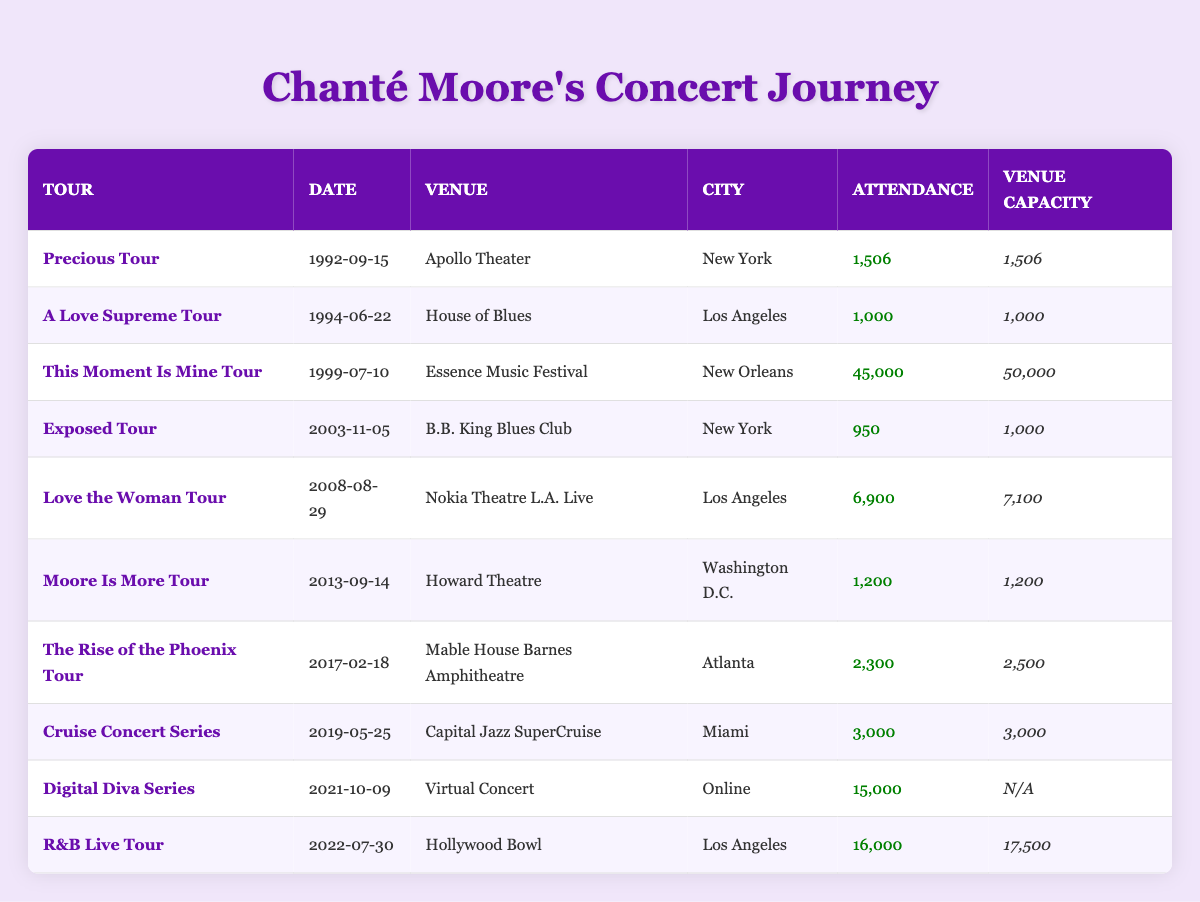What was the largest concert attendance in Chanté Moore's career? Looking at the attendance column, the highest recorded attendance is 45,000 at the Essence Music Festival on July 10, 1999.
Answer: 45,000 Which venue had the highest capacity that Chanté Moore performed at? By reviewing the venue capacity column, the highest capacity listed is 50,000 at the Essence Music Festival.
Answer: 50,000 How many concerts did Chanté Moore perform in Los Angeles? By filtering the table for concerts held in Los Angeles, there are 4 concerts listed: House of Blues, Nokia Theatre L.A. Live, and Hollywood Bowl, all in different years.
Answer: 4 What is the average attendance across all concerts? To find the average, sum the attendances: 1506 + 1000 + 45000 + 950 + 6900 + 1200 + 2300 + 3000 + 15000 + 16000 = 117,856. Then, divide by the number of concerts (10): 117,856 / 10 = 11,785.6.
Answer: 11,785.6 Did Chanté Moore perform in a venue with a capacity greater than 10,000 people? Checking the venue capacities, the Hollywood Bowl (17,500) and Essence Music Festival (50,000) both have capacities greater than 10,000. Therefore, the answer is yes.
Answer: Yes Which concert had the smallest attendance, and what was that number? The smallest attendance is found at the B.B. King Blues Club with 950 attendees on November 5, 2003.
Answer: 950 What is the difference in attendance between the largest concert and the smallest concert? The largest attendance is 45,000 and the smallest is 950. The difference is 45,000 - 950 = 44,050.
Answer: 44,050 How many concerts did Chanté perform between 2000 and 2010? By reviewing the years of concerts in the table, concerts for the years 2003, 2008 coincide with this range, which gives a total of 3 concerts performed during this period.
Answer: 3 Which tour had the lowest percentage of venue capacity filled based on attendance? Calculate the filled percentage for each concert. For B.B. King Blues Club, it is (950/1000) * 100 = 95%; for Nokia, (6900/7100) * 100 = 97.18%; and so on. The lowest is at the B.B. King's Blues Club.
Answer: Exposed Tour 